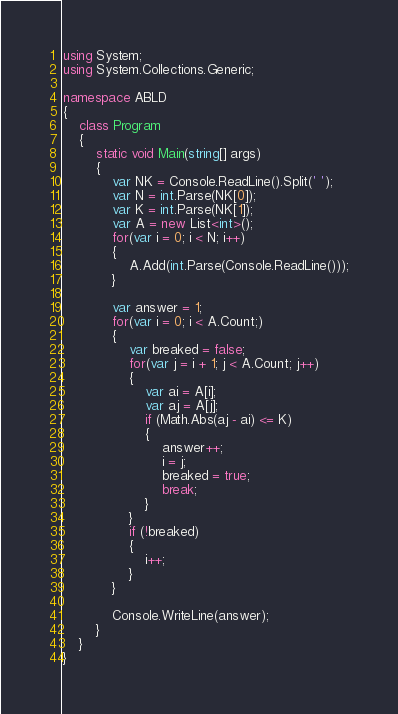<code> <loc_0><loc_0><loc_500><loc_500><_C#_>using System;
using System.Collections.Generic;

namespace ABLD
{
    class Program
    {
        static void Main(string[] args)
        {
            var NK = Console.ReadLine().Split(' ');
            var N = int.Parse(NK[0]);
            var K = int.Parse(NK[1]);
            var A = new List<int>();
            for(var i = 0; i < N; i++)
            {
                A.Add(int.Parse(Console.ReadLine()));
            }

            var answer = 1;
            for(var i = 0; i < A.Count;)
            {
                var breaked = false;
                for(var j = i + 1; j < A.Count; j++)
                {
                    var ai = A[i];
                    var aj = A[j];
                    if (Math.Abs(aj - ai) <= K)
                    {
                        answer++;
                        i = j;
                        breaked = true;
                        break;   
                    }
                }
                if (!breaked)
                {
                    i++;
                }
            }

            Console.WriteLine(answer);
        }
    }
}
</code> 